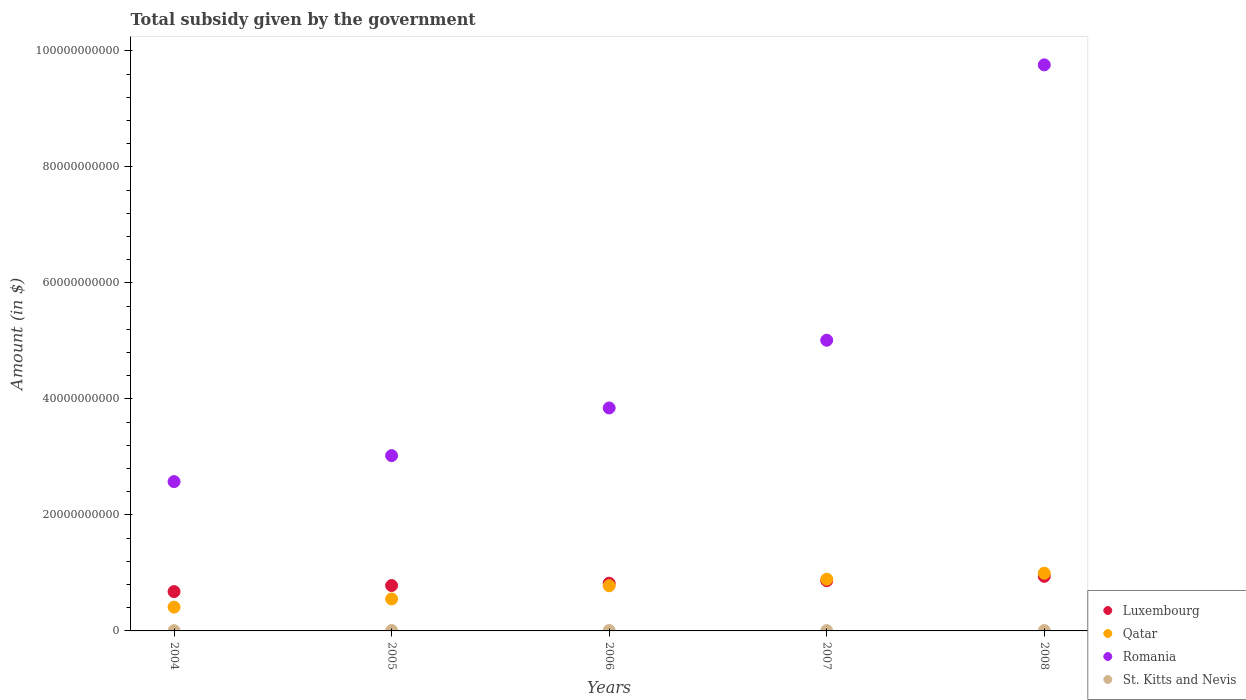How many different coloured dotlines are there?
Ensure brevity in your answer.  4. What is the total revenue collected by the government in Luxembourg in 2007?
Provide a short and direct response. 8.66e+09. Across all years, what is the maximum total revenue collected by the government in Romania?
Your response must be concise. 9.76e+1. Across all years, what is the minimum total revenue collected by the government in St. Kitts and Nevis?
Offer a very short reply. 4.43e+07. In which year was the total revenue collected by the government in St. Kitts and Nevis maximum?
Give a very brief answer. 2006. What is the total total revenue collected by the government in Qatar in the graph?
Offer a terse response. 3.63e+1. What is the difference between the total revenue collected by the government in St. Kitts and Nevis in 2004 and that in 2006?
Ensure brevity in your answer.  -2.58e+07. What is the difference between the total revenue collected by the government in Romania in 2006 and the total revenue collected by the government in St. Kitts and Nevis in 2008?
Provide a succinct answer. 3.84e+1. What is the average total revenue collected by the government in St. Kitts and Nevis per year?
Offer a very short reply. 5.87e+07. In the year 2007, what is the difference between the total revenue collected by the government in Romania and total revenue collected by the government in Qatar?
Offer a terse response. 4.12e+1. In how many years, is the total revenue collected by the government in Romania greater than 12000000000 $?
Offer a very short reply. 5. What is the ratio of the total revenue collected by the government in Qatar in 2007 to that in 2008?
Give a very brief answer. 0.9. Is the total revenue collected by the government in Qatar in 2004 less than that in 2005?
Your answer should be very brief. Yes. What is the difference between the highest and the second highest total revenue collected by the government in Qatar?
Keep it short and to the point. 1.03e+09. What is the difference between the highest and the lowest total revenue collected by the government in St. Kitts and Nevis?
Provide a succinct answer. 2.58e+07. Is the sum of the total revenue collected by the government in Qatar in 2004 and 2006 greater than the maximum total revenue collected by the government in Luxembourg across all years?
Offer a terse response. Yes. Does the total revenue collected by the government in St. Kitts and Nevis monotonically increase over the years?
Your response must be concise. No. Is the total revenue collected by the government in Romania strictly greater than the total revenue collected by the government in Luxembourg over the years?
Provide a succinct answer. Yes. How many years are there in the graph?
Make the answer very short. 5. What is the difference between two consecutive major ticks on the Y-axis?
Your response must be concise. 2.00e+1. Does the graph contain any zero values?
Offer a very short reply. No. Does the graph contain grids?
Give a very brief answer. No. Where does the legend appear in the graph?
Provide a succinct answer. Bottom right. How are the legend labels stacked?
Offer a terse response. Vertical. What is the title of the graph?
Ensure brevity in your answer.  Total subsidy given by the government. What is the label or title of the Y-axis?
Keep it short and to the point. Amount (in $). What is the Amount (in $) of Luxembourg in 2004?
Provide a succinct answer. 6.78e+09. What is the Amount (in $) of Qatar in 2004?
Your response must be concise. 4.11e+09. What is the Amount (in $) in Romania in 2004?
Keep it short and to the point. 2.57e+1. What is the Amount (in $) in St. Kitts and Nevis in 2004?
Your answer should be compact. 4.43e+07. What is the Amount (in $) of Luxembourg in 2005?
Offer a very short reply. 7.83e+09. What is the Amount (in $) of Qatar in 2005?
Your answer should be compact. 5.51e+09. What is the Amount (in $) of Romania in 2005?
Keep it short and to the point. 3.02e+1. What is the Amount (in $) in St. Kitts and Nevis in 2005?
Ensure brevity in your answer.  6.63e+07. What is the Amount (in $) in Luxembourg in 2006?
Make the answer very short. 8.23e+09. What is the Amount (in $) of Qatar in 2006?
Keep it short and to the point. 7.79e+09. What is the Amount (in $) of Romania in 2006?
Provide a succinct answer. 3.84e+1. What is the Amount (in $) of St. Kitts and Nevis in 2006?
Your answer should be very brief. 7.01e+07. What is the Amount (in $) of Luxembourg in 2007?
Your answer should be very brief. 8.66e+09. What is the Amount (in $) in Qatar in 2007?
Your answer should be very brief. 8.92e+09. What is the Amount (in $) of Romania in 2007?
Your response must be concise. 5.01e+1. What is the Amount (in $) in St. Kitts and Nevis in 2007?
Offer a terse response. 5.41e+07. What is the Amount (in $) of Luxembourg in 2008?
Provide a succinct answer. 9.41e+09. What is the Amount (in $) in Qatar in 2008?
Your answer should be very brief. 9.95e+09. What is the Amount (in $) in Romania in 2008?
Ensure brevity in your answer.  9.76e+1. What is the Amount (in $) of St. Kitts and Nevis in 2008?
Your answer should be very brief. 5.86e+07. Across all years, what is the maximum Amount (in $) of Luxembourg?
Keep it short and to the point. 9.41e+09. Across all years, what is the maximum Amount (in $) in Qatar?
Provide a short and direct response. 9.95e+09. Across all years, what is the maximum Amount (in $) in Romania?
Keep it short and to the point. 9.76e+1. Across all years, what is the maximum Amount (in $) of St. Kitts and Nevis?
Provide a succinct answer. 7.01e+07. Across all years, what is the minimum Amount (in $) in Luxembourg?
Ensure brevity in your answer.  6.78e+09. Across all years, what is the minimum Amount (in $) of Qatar?
Your answer should be compact. 4.11e+09. Across all years, what is the minimum Amount (in $) of Romania?
Offer a very short reply. 2.57e+1. Across all years, what is the minimum Amount (in $) of St. Kitts and Nevis?
Give a very brief answer. 4.43e+07. What is the total Amount (in $) in Luxembourg in the graph?
Your answer should be very brief. 4.09e+1. What is the total Amount (in $) in Qatar in the graph?
Your response must be concise. 3.63e+1. What is the total Amount (in $) in Romania in the graph?
Your answer should be compact. 2.42e+11. What is the total Amount (in $) in St. Kitts and Nevis in the graph?
Give a very brief answer. 2.93e+08. What is the difference between the Amount (in $) of Luxembourg in 2004 and that in 2005?
Offer a terse response. -1.05e+09. What is the difference between the Amount (in $) in Qatar in 2004 and that in 2005?
Give a very brief answer. -1.41e+09. What is the difference between the Amount (in $) of Romania in 2004 and that in 2005?
Provide a succinct answer. -4.48e+09. What is the difference between the Amount (in $) in St. Kitts and Nevis in 2004 and that in 2005?
Make the answer very short. -2.20e+07. What is the difference between the Amount (in $) in Luxembourg in 2004 and that in 2006?
Provide a short and direct response. -1.45e+09. What is the difference between the Amount (in $) in Qatar in 2004 and that in 2006?
Provide a succinct answer. -3.68e+09. What is the difference between the Amount (in $) in Romania in 2004 and that in 2006?
Give a very brief answer. -1.27e+1. What is the difference between the Amount (in $) in St. Kitts and Nevis in 2004 and that in 2006?
Your response must be concise. -2.58e+07. What is the difference between the Amount (in $) of Luxembourg in 2004 and that in 2007?
Give a very brief answer. -1.88e+09. What is the difference between the Amount (in $) in Qatar in 2004 and that in 2007?
Ensure brevity in your answer.  -4.81e+09. What is the difference between the Amount (in $) in Romania in 2004 and that in 2007?
Ensure brevity in your answer.  -2.44e+1. What is the difference between the Amount (in $) in St. Kitts and Nevis in 2004 and that in 2007?
Offer a very short reply. -9.80e+06. What is the difference between the Amount (in $) in Luxembourg in 2004 and that in 2008?
Provide a succinct answer. -2.63e+09. What is the difference between the Amount (in $) of Qatar in 2004 and that in 2008?
Your answer should be compact. -5.85e+09. What is the difference between the Amount (in $) of Romania in 2004 and that in 2008?
Give a very brief answer. -7.19e+1. What is the difference between the Amount (in $) of St. Kitts and Nevis in 2004 and that in 2008?
Give a very brief answer. -1.43e+07. What is the difference between the Amount (in $) of Luxembourg in 2005 and that in 2006?
Keep it short and to the point. -4.03e+08. What is the difference between the Amount (in $) of Qatar in 2005 and that in 2006?
Provide a short and direct response. -2.28e+09. What is the difference between the Amount (in $) of Romania in 2005 and that in 2006?
Ensure brevity in your answer.  -8.22e+09. What is the difference between the Amount (in $) in St. Kitts and Nevis in 2005 and that in 2006?
Keep it short and to the point. -3.80e+06. What is the difference between the Amount (in $) of Luxembourg in 2005 and that in 2007?
Provide a short and direct response. -8.35e+08. What is the difference between the Amount (in $) of Qatar in 2005 and that in 2007?
Keep it short and to the point. -3.41e+09. What is the difference between the Amount (in $) in Romania in 2005 and that in 2007?
Your answer should be very brief. -1.99e+1. What is the difference between the Amount (in $) in St. Kitts and Nevis in 2005 and that in 2007?
Ensure brevity in your answer.  1.22e+07. What is the difference between the Amount (in $) in Luxembourg in 2005 and that in 2008?
Your answer should be compact. -1.58e+09. What is the difference between the Amount (in $) in Qatar in 2005 and that in 2008?
Your answer should be compact. -4.44e+09. What is the difference between the Amount (in $) of Romania in 2005 and that in 2008?
Your response must be concise. -6.74e+1. What is the difference between the Amount (in $) of St. Kitts and Nevis in 2005 and that in 2008?
Offer a very short reply. 7.70e+06. What is the difference between the Amount (in $) in Luxembourg in 2006 and that in 2007?
Offer a terse response. -4.32e+08. What is the difference between the Amount (in $) in Qatar in 2006 and that in 2007?
Offer a very short reply. -1.13e+09. What is the difference between the Amount (in $) of Romania in 2006 and that in 2007?
Ensure brevity in your answer.  -1.17e+1. What is the difference between the Amount (in $) in St. Kitts and Nevis in 2006 and that in 2007?
Give a very brief answer. 1.60e+07. What is the difference between the Amount (in $) in Luxembourg in 2006 and that in 2008?
Provide a succinct answer. -1.18e+09. What is the difference between the Amount (in $) in Qatar in 2006 and that in 2008?
Ensure brevity in your answer.  -2.16e+09. What is the difference between the Amount (in $) of Romania in 2006 and that in 2008?
Provide a short and direct response. -5.92e+1. What is the difference between the Amount (in $) of St. Kitts and Nevis in 2006 and that in 2008?
Provide a succinct answer. 1.15e+07. What is the difference between the Amount (in $) of Luxembourg in 2007 and that in 2008?
Your answer should be compact. -7.48e+08. What is the difference between the Amount (in $) in Qatar in 2007 and that in 2008?
Give a very brief answer. -1.03e+09. What is the difference between the Amount (in $) in Romania in 2007 and that in 2008?
Offer a terse response. -4.75e+1. What is the difference between the Amount (in $) of St. Kitts and Nevis in 2007 and that in 2008?
Ensure brevity in your answer.  -4.50e+06. What is the difference between the Amount (in $) of Luxembourg in 2004 and the Amount (in $) of Qatar in 2005?
Give a very brief answer. 1.27e+09. What is the difference between the Amount (in $) of Luxembourg in 2004 and the Amount (in $) of Romania in 2005?
Offer a very short reply. -2.34e+1. What is the difference between the Amount (in $) of Luxembourg in 2004 and the Amount (in $) of St. Kitts and Nevis in 2005?
Give a very brief answer. 6.71e+09. What is the difference between the Amount (in $) in Qatar in 2004 and the Amount (in $) in Romania in 2005?
Provide a succinct answer. -2.61e+1. What is the difference between the Amount (in $) of Qatar in 2004 and the Amount (in $) of St. Kitts and Nevis in 2005?
Provide a short and direct response. 4.04e+09. What is the difference between the Amount (in $) of Romania in 2004 and the Amount (in $) of St. Kitts and Nevis in 2005?
Provide a succinct answer. 2.57e+1. What is the difference between the Amount (in $) in Luxembourg in 2004 and the Amount (in $) in Qatar in 2006?
Make the answer very short. -1.01e+09. What is the difference between the Amount (in $) of Luxembourg in 2004 and the Amount (in $) of Romania in 2006?
Provide a short and direct response. -3.17e+1. What is the difference between the Amount (in $) of Luxembourg in 2004 and the Amount (in $) of St. Kitts and Nevis in 2006?
Provide a short and direct response. 6.71e+09. What is the difference between the Amount (in $) of Qatar in 2004 and the Amount (in $) of Romania in 2006?
Make the answer very short. -3.43e+1. What is the difference between the Amount (in $) of Qatar in 2004 and the Amount (in $) of St. Kitts and Nevis in 2006?
Provide a succinct answer. 4.04e+09. What is the difference between the Amount (in $) in Romania in 2004 and the Amount (in $) in St. Kitts and Nevis in 2006?
Provide a succinct answer. 2.57e+1. What is the difference between the Amount (in $) of Luxembourg in 2004 and the Amount (in $) of Qatar in 2007?
Give a very brief answer. -2.14e+09. What is the difference between the Amount (in $) in Luxembourg in 2004 and the Amount (in $) in Romania in 2007?
Make the answer very short. -4.33e+1. What is the difference between the Amount (in $) in Luxembourg in 2004 and the Amount (in $) in St. Kitts and Nevis in 2007?
Give a very brief answer. 6.73e+09. What is the difference between the Amount (in $) of Qatar in 2004 and the Amount (in $) of Romania in 2007?
Provide a succinct answer. -4.60e+1. What is the difference between the Amount (in $) in Qatar in 2004 and the Amount (in $) in St. Kitts and Nevis in 2007?
Your response must be concise. 4.05e+09. What is the difference between the Amount (in $) of Romania in 2004 and the Amount (in $) of St. Kitts and Nevis in 2007?
Make the answer very short. 2.57e+1. What is the difference between the Amount (in $) of Luxembourg in 2004 and the Amount (in $) of Qatar in 2008?
Offer a terse response. -3.17e+09. What is the difference between the Amount (in $) in Luxembourg in 2004 and the Amount (in $) in Romania in 2008?
Provide a short and direct response. -9.08e+1. What is the difference between the Amount (in $) in Luxembourg in 2004 and the Amount (in $) in St. Kitts and Nevis in 2008?
Ensure brevity in your answer.  6.72e+09. What is the difference between the Amount (in $) in Qatar in 2004 and the Amount (in $) in Romania in 2008?
Keep it short and to the point. -9.35e+1. What is the difference between the Amount (in $) of Qatar in 2004 and the Amount (in $) of St. Kitts and Nevis in 2008?
Provide a short and direct response. 4.05e+09. What is the difference between the Amount (in $) in Romania in 2004 and the Amount (in $) in St. Kitts and Nevis in 2008?
Your answer should be compact. 2.57e+1. What is the difference between the Amount (in $) of Luxembourg in 2005 and the Amount (in $) of Qatar in 2006?
Give a very brief answer. 3.93e+07. What is the difference between the Amount (in $) in Luxembourg in 2005 and the Amount (in $) in Romania in 2006?
Make the answer very short. -3.06e+1. What is the difference between the Amount (in $) in Luxembourg in 2005 and the Amount (in $) in St. Kitts and Nevis in 2006?
Make the answer very short. 7.76e+09. What is the difference between the Amount (in $) of Qatar in 2005 and the Amount (in $) of Romania in 2006?
Keep it short and to the point. -3.29e+1. What is the difference between the Amount (in $) of Qatar in 2005 and the Amount (in $) of St. Kitts and Nevis in 2006?
Offer a very short reply. 5.44e+09. What is the difference between the Amount (in $) in Romania in 2005 and the Amount (in $) in St. Kitts and Nevis in 2006?
Provide a short and direct response. 3.02e+1. What is the difference between the Amount (in $) in Luxembourg in 2005 and the Amount (in $) in Qatar in 2007?
Your answer should be compact. -1.09e+09. What is the difference between the Amount (in $) in Luxembourg in 2005 and the Amount (in $) in Romania in 2007?
Offer a very short reply. -4.23e+1. What is the difference between the Amount (in $) in Luxembourg in 2005 and the Amount (in $) in St. Kitts and Nevis in 2007?
Offer a very short reply. 7.77e+09. What is the difference between the Amount (in $) of Qatar in 2005 and the Amount (in $) of Romania in 2007?
Offer a very short reply. -4.46e+1. What is the difference between the Amount (in $) in Qatar in 2005 and the Amount (in $) in St. Kitts and Nevis in 2007?
Keep it short and to the point. 5.46e+09. What is the difference between the Amount (in $) in Romania in 2005 and the Amount (in $) in St. Kitts and Nevis in 2007?
Keep it short and to the point. 3.02e+1. What is the difference between the Amount (in $) of Luxembourg in 2005 and the Amount (in $) of Qatar in 2008?
Give a very brief answer. -2.13e+09. What is the difference between the Amount (in $) of Luxembourg in 2005 and the Amount (in $) of Romania in 2008?
Ensure brevity in your answer.  -8.98e+1. What is the difference between the Amount (in $) of Luxembourg in 2005 and the Amount (in $) of St. Kitts and Nevis in 2008?
Give a very brief answer. 7.77e+09. What is the difference between the Amount (in $) in Qatar in 2005 and the Amount (in $) in Romania in 2008?
Make the answer very short. -9.21e+1. What is the difference between the Amount (in $) in Qatar in 2005 and the Amount (in $) in St. Kitts and Nevis in 2008?
Offer a terse response. 5.45e+09. What is the difference between the Amount (in $) in Romania in 2005 and the Amount (in $) in St. Kitts and Nevis in 2008?
Keep it short and to the point. 3.02e+1. What is the difference between the Amount (in $) of Luxembourg in 2006 and the Amount (in $) of Qatar in 2007?
Keep it short and to the point. -6.89e+08. What is the difference between the Amount (in $) of Luxembourg in 2006 and the Amount (in $) of Romania in 2007?
Make the answer very short. -4.19e+1. What is the difference between the Amount (in $) in Luxembourg in 2006 and the Amount (in $) in St. Kitts and Nevis in 2007?
Provide a short and direct response. 8.18e+09. What is the difference between the Amount (in $) of Qatar in 2006 and the Amount (in $) of Romania in 2007?
Provide a short and direct response. -4.23e+1. What is the difference between the Amount (in $) of Qatar in 2006 and the Amount (in $) of St. Kitts and Nevis in 2007?
Provide a short and direct response. 7.73e+09. What is the difference between the Amount (in $) of Romania in 2006 and the Amount (in $) of St. Kitts and Nevis in 2007?
Your answer should be very brief. 3.84e+1. What is the difference between the Amount (in $) of Luxembourg in 2006 and the Amount (in $) of Qatar in 2008?
Ensure brevity in your answer.  -1.72e+09. What is the difference between the Amount (in $) in Luxembourg in 2006 and the Amount (in $) in Romania in 2008?
Provide a short and direct response. -8.94e+1. What is the difference between the Amount (in $) in Luxembourg in 2006 and the Amount (in $) in St. Kitts and Nevis in 2008?
Your answer should be compact. 8.17e+09. What is the difference between the Amount (in $) in Qatar in 2006 and the Amount (in $) in Romania in 2008?
Keep it short and to the point. -8.98e+1. What is the difference between the Amount (in $) of Qatar in 2006 and the Amount (in $) of St. Kitts and Nevis in 2008?
Offer a very short reply. 7.73e+09. What is the difference between the Amount (in $) in Romania in 2006 and the Amount (in $) in St. Kitts and Nevis in 2008?
Give a very brief answer. 3.84e+1. What is the difference between the Amount (in $) in Luxembourg in 2007 and the Amount (in $) in Qatar in 2008?
Your answer should be compact. -1.29e+09. What is the difference between the Amount (in $) in Luxembourg in 2007 and the Amount (in $) in Romania in 2008?
Make the answer very short. -8.89e+1. What is the difference between the Amount (in $) of Luxembourg in 2007 and the Amount (in $) of St. Kitts and Nevis in 2008?
Your answer should be very brief. 8.60e+09. What is the difference between the Amount (in $) of Qatar in 2007 and the Amount (in $) of Romania in 2008?
Ensure brevity in your answer.  -8.87e+1. What is the difference between the Amount (in $) of Qatar in 2007 and the Amount (in $) of St. Kitts and Nevis in 2008?
Provide a short and direct response. 8.86e+09. What is the difference between the Amount (in $) of Romania in 2007 and the Amount (in $) of St. Kitts and Nevis in 2008?
Offer a terse response. 5.01e+1. What is the average Amount (in $) in Luxembourg per year?
Ensure brevity in your answer.  8.18e+09. What is the average Amount (in $) in Qatar per year?
Your response must be concise. 7.26e+09. What is the average Amount (in $) in Romania per year?
Offer a very short reply. 4.84e+1. What is the average Amount (in $) in St. Kitts and Nevis per year?
Provide a short and direct response. 5.87e+07. In the year 2004, what is the difference between the Amount (in $) of Luxembourg and Amount (in $) of Qatar?
Give a very brief answer. 2.68e+09. In the year 2004, what is the difference between the Amount (in $) of Luxembourg and Amount (in $) of Romania?
Give a very brief answer. -1.90e+1. In the year 2004, what is the difference between the Amount (in $) of Luxembourg and Amount (in $) of St. Kitts and Nevis?
Provide a succinct answer. 6.74e+09. In the year 2004, what is the difference between the Amount (in $) of Qatar and Amount (in $) of Romania?
Offer a terse response. -2.16e+1. In the year 2004, what is the difference between the Amount (in $) of Qatar and Amount (in $) of St. Kitts and Nevis?
Give a very brief answer. 4.06e+09. In the year 2004, what is the difference between the Amount (in $) of Romania and Amount (in $) of St. Kitts and Nevis?
Offer a terse response. 2.57e+1. In the year 2005, what is the difference between the Amount (in $) of Luxembourg and Amount (in $) of Qatar?
Your response must be concise. 2.32e+09. In the year 2005, what is the difference between the Amount (in $) of Luxembourg and Amount (in $) of Romania?
Offer a terse response. -2.24e+1. In the year 2005, what is the difference between the Amount (in $) of Luxembourg and Amount (in $) of St. Kitts and Nevis?
Make the answer very short. 7.76e+09. In the year 2005, what is the difference between the Amount (in $) in Qatar and Amount (in $) in Romania?
Your response must be concise. -2.47e+1. In the year 2005, what is the difference between the Amount (in $) in Qatar and Amount (in $) in St. Kitts and Nevis?
Ensure brevity in your answer.  5.44e+09. In the year 2005, what is the difference between the Amount (in $) of Romania and Amount (in $) of St. Kitts and Nevis?
Keep it short and to the point. 3.02e+1. In the year 2006, what is the difference between the Amount (in $) in Luxembourg and Amount (in $) in Qatar?
Provide a short and direct response. 4.43e+08. In the year 2006, what is the difference between the Amount (in $) in Luxembourg and Amount (in $) in Romania?
Your answer should be compact. -3.02e+1. In the year 2006, what is the difference between the Amount (in $) of Luxembourg and Amount (in $) of St. Kitts and Nevis?
Your answer should be compact. 8.16e+09. In the year 2006, what is the difference between the Amount (in $) of Qatar and Amount (in $) of Romania?
Keep it short and to the point. -3.07e+1. In the year 2006, what is the difference between the Amount (in $) in Qatar and Amount (in $) in St. Kitts and Nevis?
Make the answer very short. 7.72e+09. In the year 2006, what is the difference between the Amount (in $) in Romania and Amount (in $) in St. Kitts and Nevis?
Offer a very short reply. 3.84e+1. In the year 2007, what is the difference between the Amount (in $) of Luxembourg and Amount (in $) of Qatar?
Your answer should be very brief. -2.57e+08. In the year 2007, what is the difference between the Amount (in $) in Luxembourg and Amount (in $) in Romania?
Keep it short and to the point. -4.15e+1. In the year 2007, what is the difference between the Amount (in $) in Luxembourg and Amount (in $) in St. Kitts and Nevis?
Keep it short and to the point. 8.61e+09. In the year 2007, what is the difference between the Amount (in $) in Qatar and Amount (in $) in Romania?
Offer a terse response. -4.12e+1. In the year 2007, what is the difference between the Amount (in $) in Qatar and Amount (in $) in St. Kitts and Nevis?
Offer a very short reply. 8.87e+09. In the year 2007, what is the difference between the Amount (in $) of Romania and Amount (in $) of St. Kitts and Nevis?
Your answer should be compact. 5.01e+1. In the year 2008, what is the difference between the Amount (in $) of Luxembourg and Amount (in $) of Qatar?
Make the answer very short. -5.42e+08. In the year 2008, what is the difference between the Amount (in $) in Luxembourg and Amount (in $) in Romania?
Your answer should be compact. -8.82e+1. In the year 2008, what is the difference between the Amount (in $) of Luxembourg and Amount (in $) of St. Kitts and Nevis?
Offer a terse response. 9.35e+09. In the year 2008, what is the difference between the Amount (in $) of Qatar and Amount (in $) of Romania?
Offer a very short reply. -8.77e+1. In the year 2008, what is the difference between the Amount (in $) in Qatar and Amount (in $) in St. Kitts and Nevis?
Your answer should be compact. 9.89e+09. In the year 2008, what is the difference between the Amount (in $) in Romania and Amount (in $) in St. Kitts and Nevis?
Keep it short and to the point. 9.75e+1. What is the ratio of the Amount (in $) of Luxembourg in 2004 to that in 2005?
Make the answer very short. 0.87. What is the ratio of the Amount (in $) in Qatar in 2004 to that in 2005?
Provide a short and direct response. 0.74. What is the ratio of the Amount (in $) in Romania in 2004 to that in 2005?
Offer a very short reply. 0.85. What is the ratio of the Amount (in $) of St. Kitts and Nevis in 2004 to that in 2005?
Your answer should be compact. 0.67. What is the ratio of the Amount (in $) of Luxembourg in 2004 to that in 2006?
Offer a terse response. 0.82. What is the ratio of the Amount (in $) of Qatar in 2004 to that in 2006?
Your answer should be very brief. 0.53. What is the ratio of the Amount (in $) in Romania in 2004 to that in 2006?
Provide a short and direct response. 0.67. What is the ratio of the Amount (in $) in St. Kitts and Nevis in 2004 to that in 2006?
Offer a very short reply. 0.63. What is the ratio of the Amount (in $) of Luxembourg in 2004 to that in 2007?
Offer a very short reply. 0.78. What is the ratio of the Amount (in $) in Qatar in 2004 to that in 2007?
Make the answer very short. 0.46. What is the ratio of the Amount (in $) of Romania in 2004 to that in 2007?
Offer a terse response. 0.51. What is the ratio of the Amount (in $) of St. Kitts and Nevis in 2004 to that in 2007?
Give a very brief answer. 0.82. What is the ratio of the Amount (in $) of Luxembourg in 2004 to that in 2008?
Give a very brief answer. 0.72. What is the ratio of the Amount (in $) of Qatar in 2004 to that in 2008?
Provide a short and direct response. 0.41. What is the ratio of the Amount (in $) in Romania in 2004 to that in 2008?
Offer a very short reply. 0.26. What is the ratio of the Amount (in $) in St. Kitts and Nevis in 2004 to that in 2008?
Provide a short and direct response. 0.76. What is the ratio of the Amount (in $) of Luxembourg in 2005 to that in 2006?
Offer a terse response. 0.95. What is the ratio of the Amount (in $) of Qatar in 2005 to that in 2006?
Make the answer very short. 0.71. What is the ratio of the Amount (in $) of Romania in 2005 to that in 2006?
Offer a terse response. 0.79. What is the ratio of the Amount (in $) in St. Kitts and Nevis in 2005 to that in 2006?
Keep it short and to the point. 0.95. What is the ratio of the Amount (in $) of Luxembourg in 2005 to that in 2007?
Your answer should be compact. 0.9. What is the ratio of the Amount (in $) in Qatar in 2005 to that in 2007?
Offer a very short reply. 0.62. What is the ratio of the Amount (in $) in Romania in 2005 to that in 2007?
Give a very brief answer. 0.6. What is the ratio of the Amount (in $) in St. Kitts and Nevis in 2005 to that in 2007?
Provide a short and direct response. 1.23. What is the ratio of the Amount (in $) of Luxembourg in 2005 to that in 2008?
Ensure brevity in your answer.  0.83. What is the ratio of the Amount (in $) of Qatar in 2005 to that in 2008?
Provide a succinct answer. 0.55. What is the ratio of the Amount (in $) in Romania in 2005 to that in 2008?
Your answer should be very brief. 0.31. What is the ratio of the Amount (in $) in St. Kitts and Nevis in 2005 to that in 2008?
Offer a terse response. 1.13. What is the ratio of the Amount (in $) of Luxembourg in 2006 to that in 2007?
Offer a terse response. 0.95. What is the ratio of the Amount (in $) of Qatar in 2006 to that in 2007?
Make the answer very short. 0.87. What is the ratio of the Amount (in $) of Romania in 2006 to that in 2007?
Offer a very short reply. 0.77. What is the ratio of the Amount (in $) in St. Kitts and Nevis in 2006 to that in 2007?
Keep it short and to the point. 1.3. What is the ratio of the Amount (in $) in Luxembourg in 2006 to that in 2008?
Offer a terse response. 0.87. What is the ratio of the Amount (in $) of Qatar in 2006 to that in 2008?
Your answer should be compact. 0.78. What is the ratio of the Amount (in $) of Romania in 2006 to that in 2008?
Keep it short and to the point. 0.39. What is the ratio of the Amount (in $) in St. Kitts and Nevis in 2006 to that in 2008?
Provide a short and direct response. 1.2. What is the ratio of the Amount (in $) of Luxembourg in 2007 to that in 2008?
Your answer should be very brief. 0.92. What is the ratio of the Amount (in $) in Qatar in 2007 to that in 2008?
Offer a very short reply. 0.9. What is the ratio of the Amount (in $) of Romania in 2007 to that in 2008?
Your answer should be compact. 0.51. What is the ratio of the Amount (in $) in St. Kitts and Nevis in 2007 to that in 2008?
Your response must be concise. 0.92. What is the difference between the highest and the second highest Amount (in $) of Luxembourg?
Your answer should be compact. 7.48e+08. What is the difference between the highest and the second highest Amount (in $) in Qatar?
Ensure brevity in your answer.  1.03e+09. What is the difference between the highest and the second highest Amount (in $) of Romania?
Ensure brevity in your answer.  4.75e+1. What is the difference between the highest and the second highest Amount (in $) in St. Kitts and Nevis?
Keep it short and to the point. 3.80e+06. What is the difference between the highest and the lowest Amount (in $) of Luxembourg?
Offer a terse response. 2.63e+09. What is the difference between the highest and the lowest Amount (in $) of Qatar?
Provide a succinct answer. 5.85e+09. What is the difference between the highest and the lowest Amount (in $) of Romania?
Make the answer very short. 7.19e+1. What is the difference between the highest and the lowest Amount (in $) of St. Kitts and Nevis?
Provide a succinct answer. 2.58e+07. 